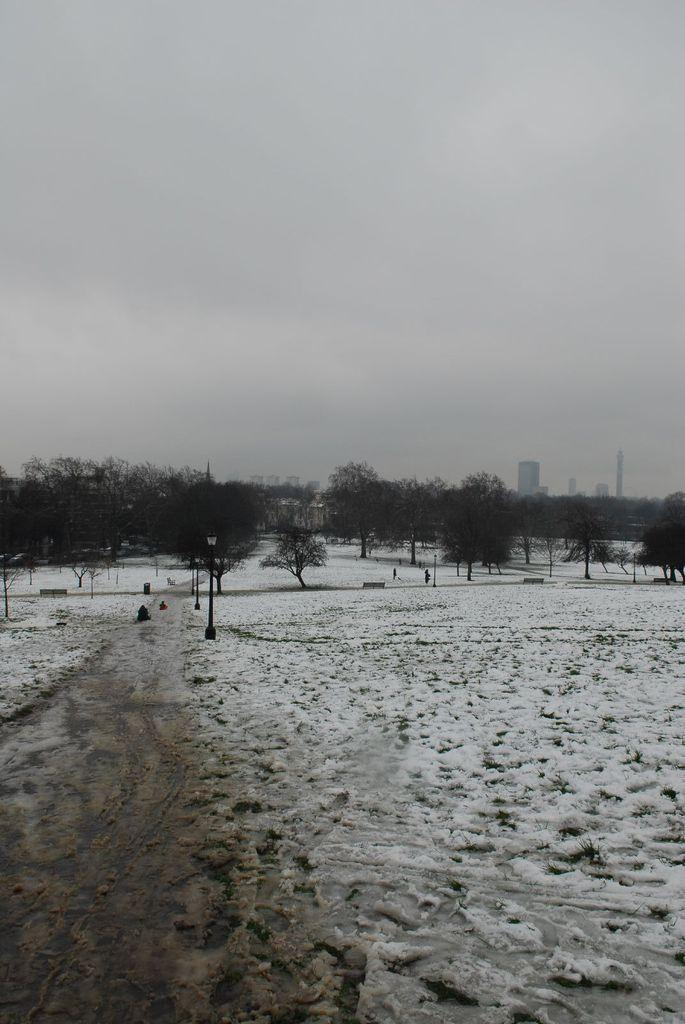What can be seen in the middle of the image? There are trees and buildings in the middle of the image. What is the condition of the ice in the image? The ice is visible in the image. What is visible at the top of the image? The sky is visible at the top of the image. Where is the advertisement for straw located in the image? There is no advertisement for straw present in the image. Can you tell me how deep the quicksand is in the image? There is no quicksand present in the image. 